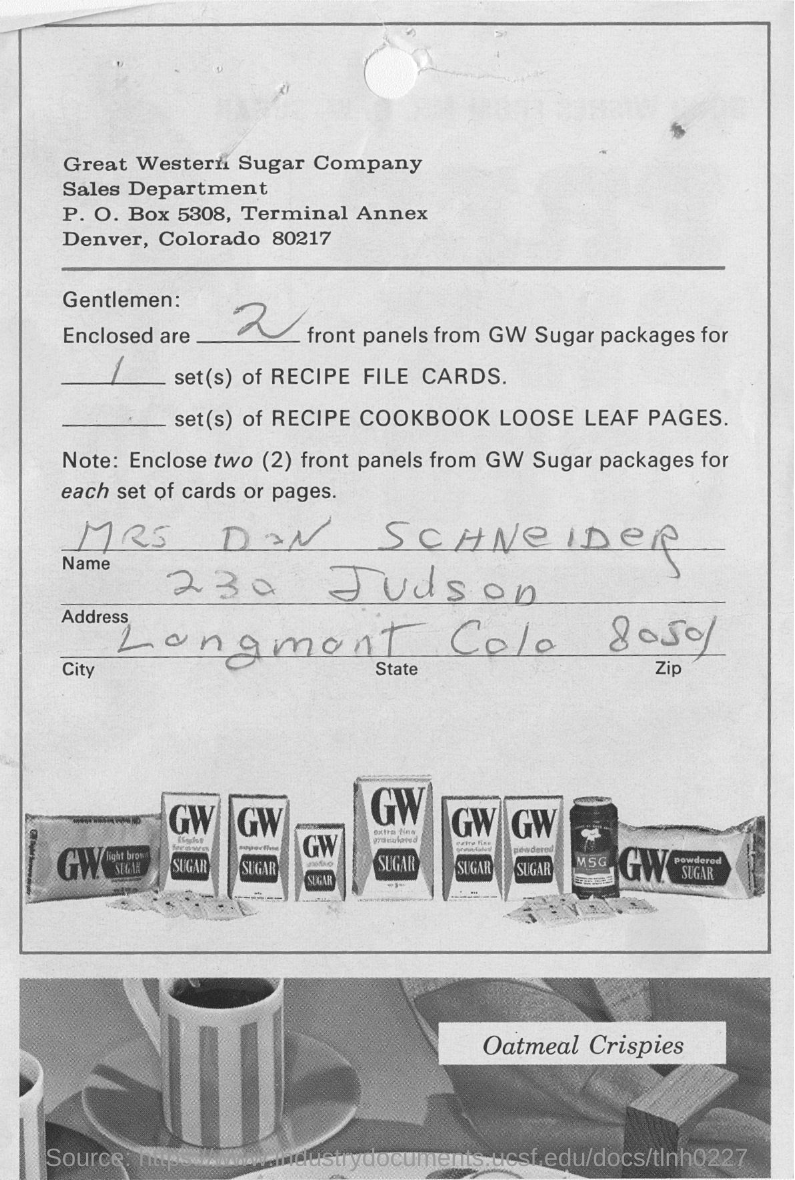Point out several critical features in this image. The sales department of a company named Great Western Sugar Company is located in slip. The number of front panels enclosed in GW sugar packages is two. The name on the slip is Mrs. Don Schneider. The speaker is curious about the type of meal that is being referred to as "meal crispies." They believe that the meal in question is oatmeal. 